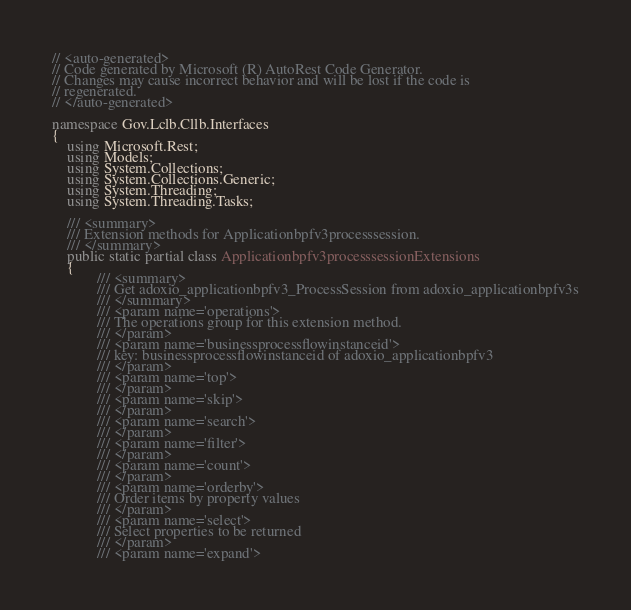Convert code to text. <code><loc_0><loc_0><loc_500><loc_500><_C#_>// <auto-generated>
// Code generated by Microsoft (R) AutoRest Code Generator.
// Changes may cause incorrect behavior and will be lost if the code is
// regenerated.
// </auto-generated>

namespace Gov.Lclb.Cllb.Interfaces
{
    using Microsoft.Rest;
    using Models;
    using System.Collections;
    using System.Collections.Generic;
    using System.Threading;
    using System.Threading.Tasks;

    /// <summary>
    /// Extension methods for Applicationbpfv3processsession.
    /// </summary>
    public static partial class Applicationbpfv3processsessionExtensions
    {
            /// <summary>
            /// Get adoxio_applicationbpfv3_ProcessSession from adoxio_applicationbpfv3s
            /// </summary>
            /// <param name='operations'>
            /// The operations group for this extension method.
            /// </param>
            /// <param name='businessprocessflowinstanceid'>
            /// key: businessprocessflowinstanceid of adoxio_applicationbpfv3
            /// </param>
            /// <param name='top'>
            /// </param>
            /// <param name='skip'>
            /// </param>
            /// <param name='search'>
            /// </param>
            /// <param name='filter'>
            /// </param>
            /// <param name='count'>
            /// </param>
            /// <param name='orderby'>
            /// Order items by property values
            /// </param>
            /// <param name='select'>
            /// Select properties to be returned
            /// </param>
            /// <param name='expand'></code> 